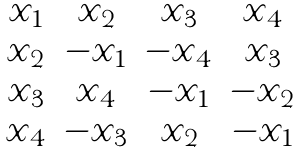<formula> <loc_0><loc_0><loc_500><loc_500>\begin{matrix} x _ { 1 } & x _ { 2 } & x _ { 3 } & x _ { 4 } \\ x _ { 2 } & - x _ { 1 } & - x _ { 4 } & x _ { 3 } \\ x _ { 3 } & x _ { 4 } & - x _ { 1 } & - x _ { 2 } \\ x _ { 4 } & - x _ { 3 } & x _ { 2 } & - x _ { 1 } \end{matrix}</formula> 